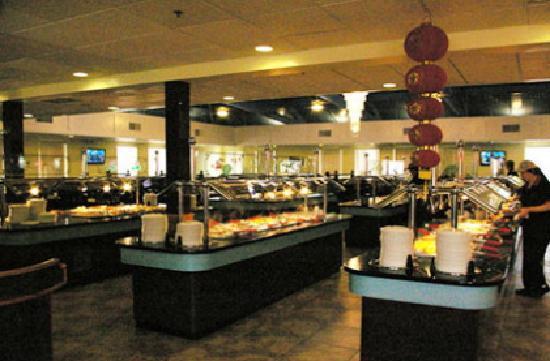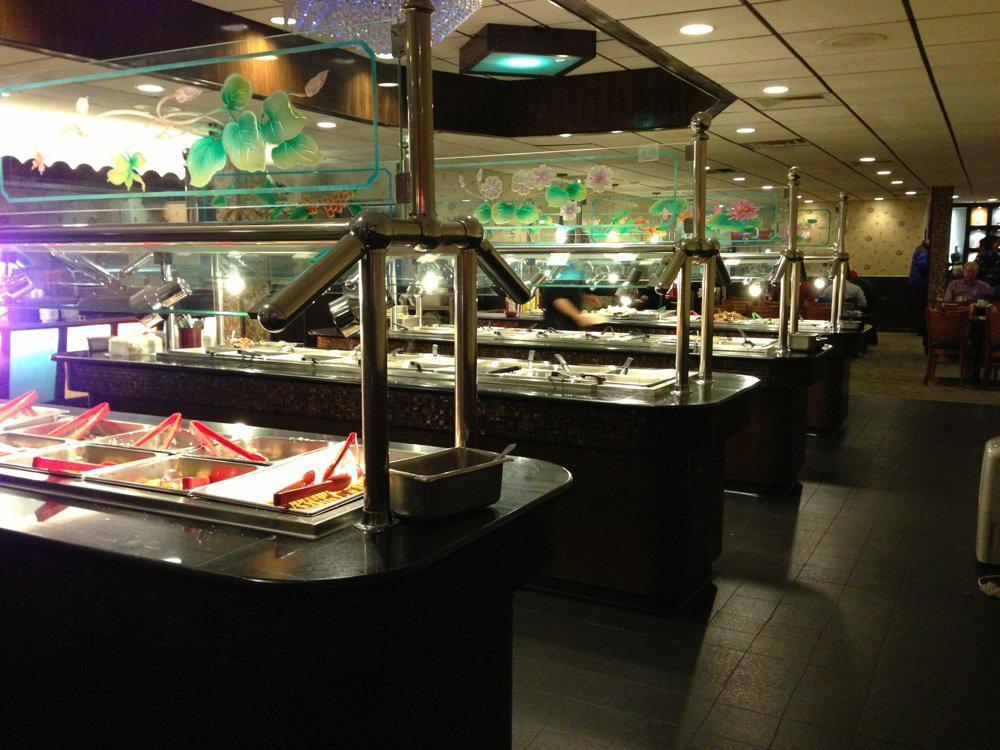The first image is the image on the left, the second image is the image on the right. For the images displayed, is the sentence "The right image shows tongs by rows of steel bins full of food, and the left image includes a white food plate surrounded by other dishware items on a dark table." factually correct? Answer yes or no. No. The first image is the image on the left, the second image is the image on the right. Considering the images on both sides, is "All the tongs are black and sliver." valid? Answer yes or no. No. 